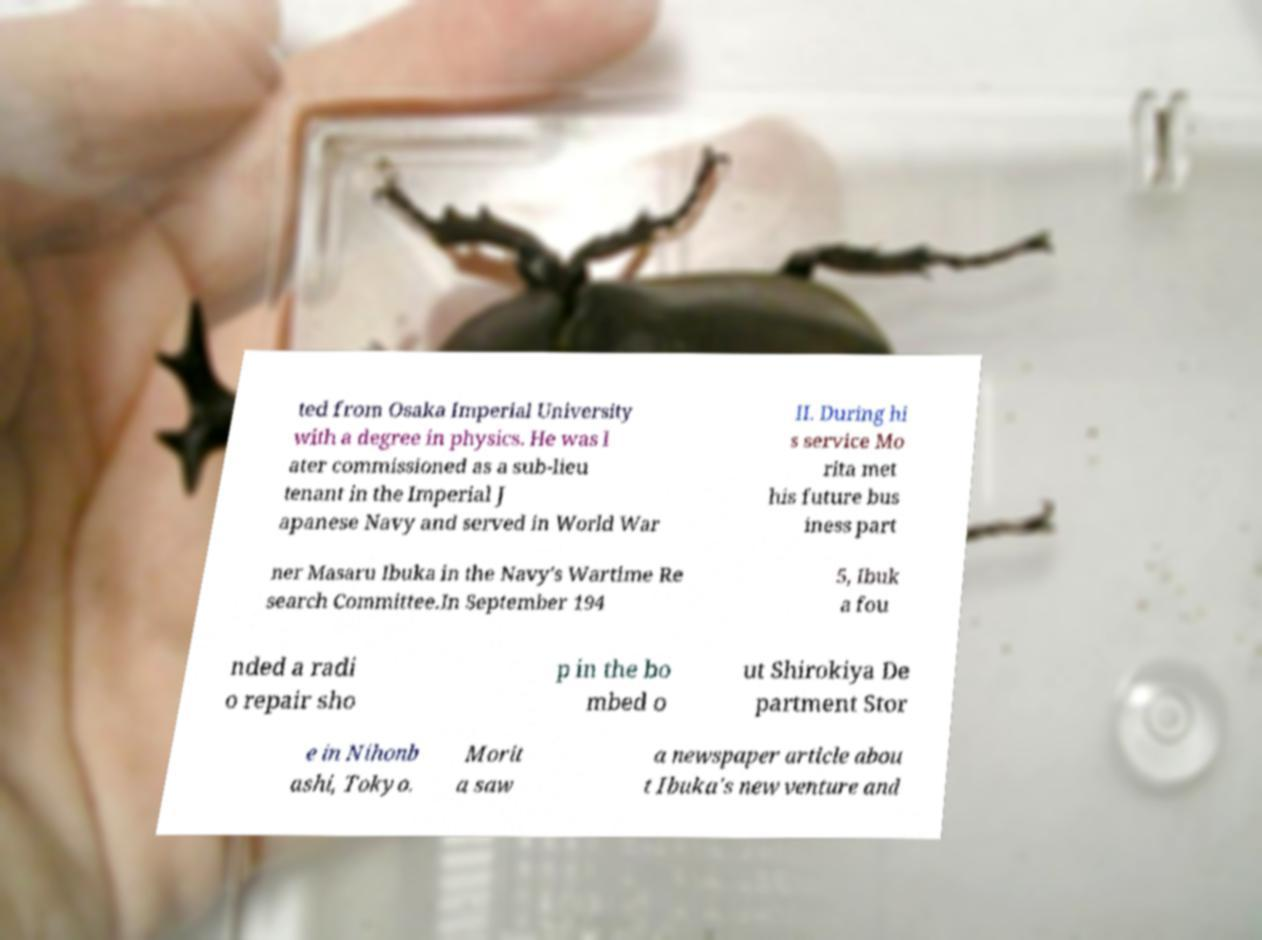Could you assist in decoding the text presented in this image and type it out clearly? ted from Osaka Imperial University with a degree in physics. He was l ater commissioned as a sub-lieu tenant in the Imperial J apanese Navy and served in World War II. During hi s service Mo rita met his future bus iness part ner Masaru Ibuka in the Navy's Wartime Re search Committee.In September 194 5, Ibuk a fou nded a radi o repair sho p in the bo mbed o ut Shirokiya De partment Stor e in Nihonb ashi, Tokyo. Morit a saw a newspaper article abou t Ibuka's new venture and 